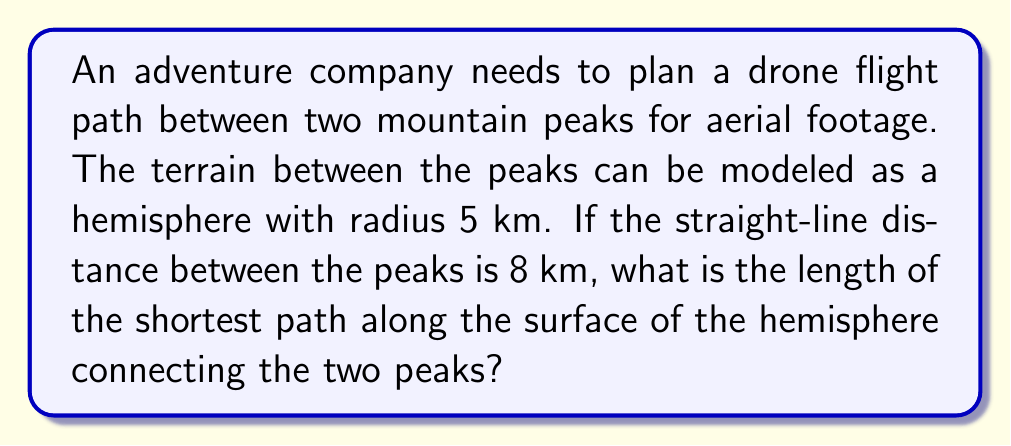Can you solve this math problem? To solve this problem, we'll use concepts from spherical geometry:

1) First, we need to find the central angle $\theta$ between the two peaks. We can do this using the formula for the chord length of a sphere:

   $$c = 2R \sin(\frac{\theta}{2})$$

   where $c$ is the chord length (straight-line distance), $R$ is the radius, and $\theta$ is the central angle.

2) Substituting our values:

   $$8 = 2(5) \sin(\frac{\theta}{2})$$

3) Solving for $\theta$:

   $$\frac{8}{10} = \sin(\frac{\theta}{2})$$
   $$\frac{\theta}{2} = \arcsin(0.8)$$
   $$\theta = 2\arcsin(0.8)$$

4) The shortest path between two points on a sphere is along the great circle connecting them. The length of this path is given by the arc length formula:

   $$s = R\theta$$

   where $s$ is the arc length, $R$ is the radius, and $\theta$ is in radians.

5) Substituting our values:

   $$s = 5 \cdot 2\arcsin(0.8)$$

6) Calculating the final result:

   $$s \approx 8.6415$$ km
Answer: $5 \cdot 2\arcsin(0.8) \approx 8.6415$ km 